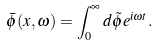<formula> <loc_0><loc_0><loc_500><loc_500>\bar { \phi } ( x , \omega ) = \int ^ { \infty } _ { 0 } d \tilde { \phi } e ^ { i \omega t } .</formula> 